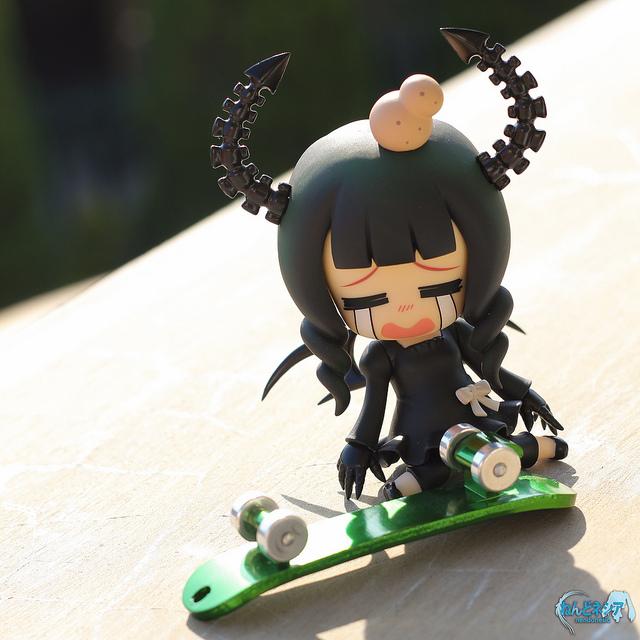What color is the toy skateboard?
Answer briefly. Green. What character is that on the skateboard?
Answer briefly. Anime. Is that a cartoon character?
Keep it brief. Yes. 